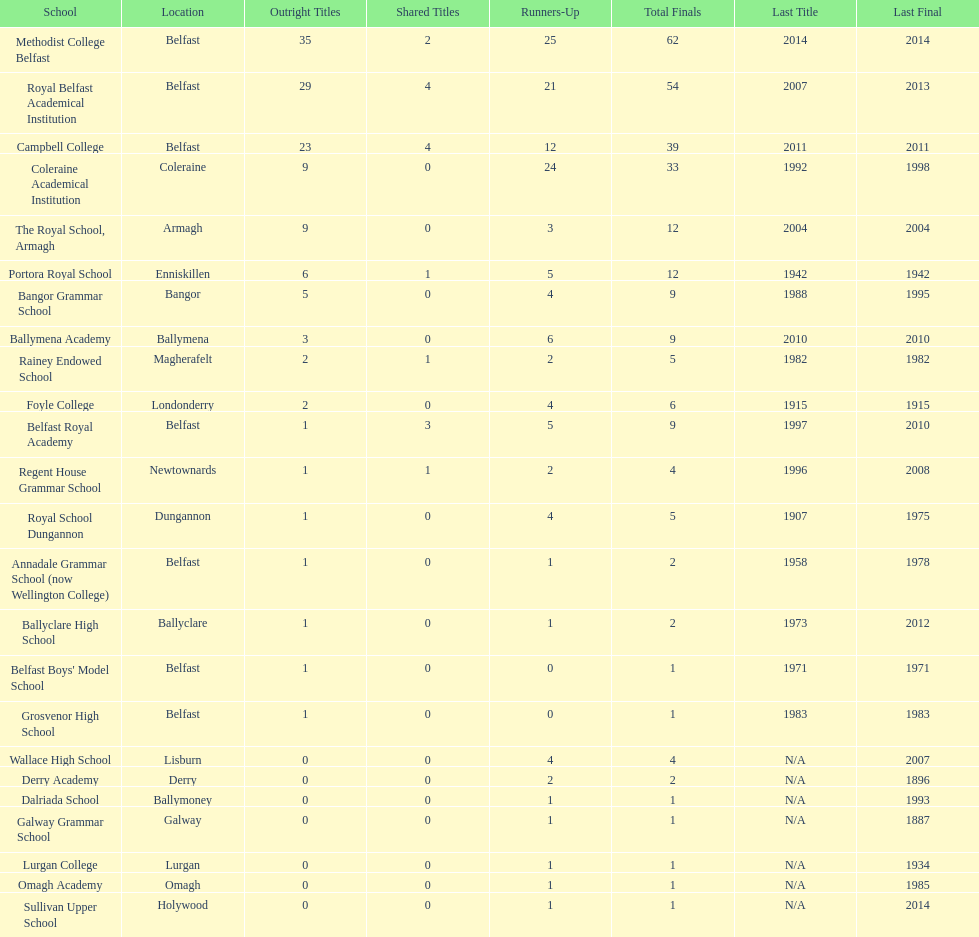Between campbell college and regent house grammar school, who possesses the newest title success? Campbell College. 